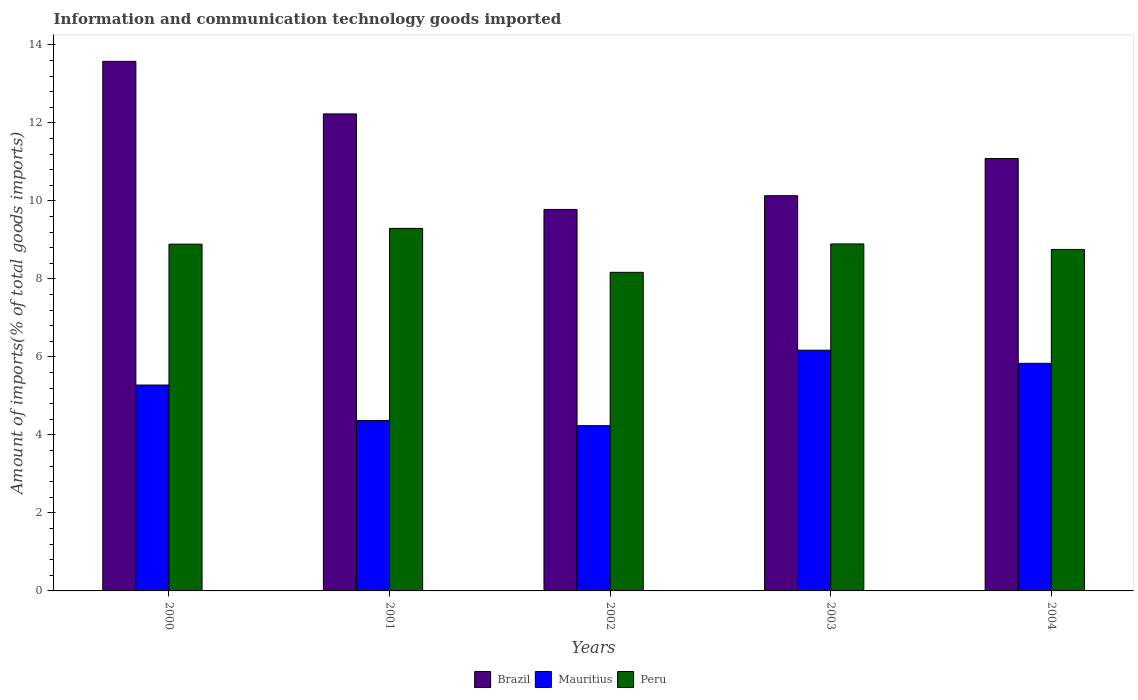How many groups of bars are there?
Give a very brief answer. 5. Are the number of bars on each tick of the X-axis equal?
Provide a succinct answer. Yes. What is the label of the 1st group of bars from the left?
Your answer should be very brief. 2000. In how many cases, is the number of bars for a given year not equal to the number of legend labels?
Keep it short and to the point. 0. What is the amount of goods imported in Mauritius in 2003?
Provide a short and direct response. 6.17. Across all years, what is the maximum amount of goods imported in Mauritius?
Provide a short and direct response. 6.17. Across all years, what is the minimum amount of goods imported in Peru?
Give a very brief answer. 8.17. In which year was the amount of goods imported in Peru minimum?
Provide a succinct answer. 2002. What is the total amount of goods imported in Mauritius in the graph?
Keep it short and to the point. 25.89. What is the difference between the amount of goods imported in Mauritius in 2001 and that in 2003?
Offer a very short reply. -1.8. What is the difference between the amount of goods imported in Mauritius in 2001 and the amount of goods imported in Brazil in 2002?
Offer a terse response. -5.41. What is the average amount of goods imported in Mauritius per year?
Offer a very short reply. 5.18. In the year 2003, what is the difference between the amount of goods imported in Mauritius and amount of goods imported in Brazil?
Your response must be concise. -3.96. In how many years, is the amount of goods imported in Mauritius greater than 6.4 %?
Give a very brief answer. 0. What is the ratio of the amount of goods imported in Mauritius in 2000 to that in 2001?
Your answer should be compact. 1.21. Is the amount of goods imported in Peru in 2001 less than that in 2003?
Your response must be concise. No. What is the difference between the highest and the second highest amount of goods imported in Peru?
Your answer should be very brief. 0.4. What is the difference between the highest and the lowest amount of goods imported in Brazil?
Offer a terse response. 3.8. What does the 2nd bar from the right in 2004 represents?
Your answer should be very brief. Mauritius. Is it the case that in every year, the sum of the amount of goods imported in Brazil and amount of goods imported in Peru is greater than the amount of goods imported in Mauritius?
Offer a very short reply. Yes. Are the values on the major ticks of Y-axis written in scientific E-notation?
Provide a short and direct response. No. Does the graph contain any zero values?
Keep it short and to the point. No. How many legend labels are there?
Your response must be concise. 3. How are the legend labels stacked?
Offer a very short reply. Horizontal. What is the title of the graph?
Your response must be concise. Information and communication technology goods imported. What is the label or title of the Y-axis?
Offer a very short reply. Amount of imports(% of total goods imports). What is the Amount of imports(% of total goods imports) of Brazil in 2000?
Your answer should be very brief. 13.58. What is the Amount of imports(% of total goods imports) of Mauritius in 2000?
Offer a terse response. 5.28. What is the Amount of imports(% of total goods imports) of Peru in 2000?
Your response must be concise. 8.89. What is the Amount of imports(% of total goods imports) in Brazil in 2001?
Keep it short and to the point. 12.23. What is the Amount of imports(% of total goods imports) of Mauritius in 2001?
Make the answer very short. 4.37. What is the Amount of imports(% of total goods imports) in Peru in 2001?
Offer a terse response. 9.3. What is the Amount of imports(% of total goods imports) in Brazil in 2002?
Give a very brief answer. 9.78. What is the Amount of imports(% of total goods imports) of Mauritius in 2002?
Your answer should be compact. 4.24. What is the Amount of imports(% of total goods imports) in Peru in 2002?
Provide a short and direct response. 8.17. What is the Amount of imports(% of total goods imports) in Brazil in 2003?
Your answer should be compact. 10.13. What is the Amount of imports(% of total goods imports) of Mauritius in 2003?
Give a very brief answer. 6.17. What is the Amount of imports(% of total goods imports) in Peru in 2003?
Your response must be concise. 8.9. What is the Amount of imports(% of total goods imports) in Brazil in 2004?
Keep it short and to the point. 11.09. What is the Amount of imports(% of total goods imports) in Mauritius in 2004?
Offer a terse response. 5.84. What is the Amount of imports(% of total goods imports) of Peru in 2004?
Provide a succinct answer. 8.76. Across all years, what is the maximum Amount of imports(% of total goods imports) in Brazil?
Provide a short and direct response. 13.58. Across all years, what is the maximum Amount of imports(% of total goods imports) in Mauritius?
Provide a short and direct response. 6.17. Across all years, what is the maximum Amount of imports(% of total goods imports) in Peru?
Offer a terse response. 9.3. Across all years, what is the minimum Amount of imports(% of total goods imports) in Brazil?
Provide a succinct answer. 9.78. Across all years, what is the minimum Amount of imports(% of total goods imports) of Mauritius?
Your answer should be very brief. 4.24. Across all years, what is the minimum Amount of imports(% of total goods imports) of Peru?
Give a very brief answer. 8.17. What is the total Amount of imports(% of total goods imports) of Brazil in the graph?
Provide a short and direct response. 56.81. What is the total Amount of imports(% of total goods imports) in Mauritius in the graph?
Make the answer very short. 25.89. What is the total Amount of imports(% of total goods imports) of Peru in the graph?
Provide a succinct answer. 44.01. What is the difference between the Amount of imports(% of total goods imports) of Brazil in 2000 and that in 2001?
Give a very brief answer. 1.35. What is the difference between the Amount of imports(% of total goods imports) in Mauritius in 2000 and that in 2001?
Keep it short and to the point. 0.91. What is the difference between the Amount of imports(% of total goods imports) of Peru in 2000 and that in 2001?
Offer a very short reply. -0.4. What is the difference between the Amount of imports(% of total goods imports) of Brazil in 2000 and that in 2002?
Provide a succinct answer. 3.8. What is the difference between the Amount of imports(% of total goods imports) in Mauritius in 2000 and that in 2002?
Provide a short and direct response. 1.04. What is the difference between the Amount of imports(% of total goods imports) in Peru in 2000 and that in 2002?
Your response must be concise. 0.72. What is the difference between the Amount of imports(% of total goods imports) in Brazil in 2000 and that in 2003?
Your answer should be compact. 3.44. What is the difference between the Amount of imports(% of total goods imports) of Mauritius in 2000 and that in 2003?
Ensure brevity in your answer.  -0.89. What is the difference between the Amount of imports(% of total goods imports) of Peru in 2000 and that in 2003?
Make the answer very short. -0.01. What is the difference between the Amount of imports(% of total goods imports) in Brazil in 2000 and that in 2004?
Make the answer very short. 2.49. What is the difference between the Amount of imports(% of total goods imports) of Mauritius in 2000 and that in 2004?
Keep it short and to the point. -0.56. What is the difference between the Amount of imports(% of total goods imports) of Peru in 2000 and that in 2004?
Your answer should be compact. 0.14. What is the difference between the Amount of imports(% of total goods imports) of Brazil in 2001 and that in 2002?
Offer a very short reply. 2.45. What is the difference between the Amount of imports(% of total goods imports) in Mauritius in 2001 and that in 2002?
Offer a terse response. 0.13. What is the difference between the Amount of imports(% of total goods imports) of Peru in 2001 and that in 2002?
Make the answer very short. 1.13. What is the difference between the Amount of imports(% of total goods imports) in Brazil in 2001 and that in 2003?
Your answer should be compact. 2.1. What is the difference between the Amount of imports(% of total goods imports) of Mauritius in 2001 and that in 2003?
Ensure brevity in your answer.  -1.8. What is the difference between the Amount of imports(% of total goods imports) in Peru in 2001 and that in 2003?
Ensure brevity in your answer.  0.4. What is the difference between the Amount of imports(% of total goods imports) of Brazil in 2001 and that in 2004?
Your response must be concise. 1.14. What is the difference between the Amount of imports(% of total goods imports) in Mauritius in 2001 and that in 2004?
Your answer should be compact. -1.46. What is the difference between the Amount of imports(% of total goods imports) in Peru in 2001 and that in 2004?
Keep it short and to the point. 0.54. What is the difference between the Amount of imports(% of total goods imports) in Brazil in 2002 and that in 2003?
Give a very brief answer. -0.35. What is the difference between the Amount of imports(% of total goods imports) in Mauritius in 2002 and that in 2003?
Make the answer very short. -1.94. What is the difference between the Amount of imports(% of total goods imports) in Peru in 2002 and that in 2003?
Provide a short and direct response. -0.73. What is the difference between the Amount of imports(% of total goods imports) in Brazil in 2002 and that in 2004?
Provide a succinct answer. -1.31. What is the difference between the Amount of imports(% of total goods imports) of Mauritius in 2002 and that in 2004?
Your response must be concise. -1.6. What is the difference between the Amount of imports(% of total goods imports) in Peru in 2002 and that in 2004?
Your response must be concise. -0.59. What is the difference between the Amount of imports(% of total goods imports) in Brazil in 2003 and that in 2004?
Offer a very short reply. -0.95. What is the difference between the Amount of imports(% of total goods imports) in Mauritius in 2003 and that in 2004?
Ensure brevity in your answer.  0.34. What is the difference between the Amount of imports(% of total goods imports) of Peru in 2003 and that in 2004?
Offer a very short reply. 0.14. What is the difference between the Amount of imports(% of total goods imports) of Brazil in 2000 and the Amount of imports(% of total goods imports) of Mauritius in 2001?
Provide a succinct answer. 9.21. What is the difference between the Amount of imports(% of total goods imports) of Brazil in 2000 and the Amount of imports(% of total goods imports) of Peru in 2001?
Give a very brief answer. 4.28. What is the difference between the Amount of imports(% of total goods imports) in Mauritius in 2000 and the Amount of imports(% of total goods imports) in Peru in 2001?
Provide a short and direct response. -4.02. What is the difference between the Amount of imports(% of total goods imports) of Brazil in 2000 and the Amount of imports(% of total goods imports) of Mauritius in 2002?
Provide a short and direct response. 9.34. What is the difference between the Amount of imports(% of total goods imports) of Brazil in 2000 and the Amount of imports(% of total goods imports) of Peru in 2002?
Offer a very short reply. 5.41. What is the difference between the Amount of imports(% of total goods imports) in Mauritius in 2000 and the Amount of imports(% of total goods imports) in Peru in 2002?
Offer a terse response. -2.89. What is the difference between the Amount of imports(% of total goods imports) of Brazil in 2000 and the Amount of imports(% of total goods imports) of Mauritius in 2003?
Your answer should be very brief. 7.41. What is the difference between the Amount of imports(% of total goods imports) of Brazil in 2000 and the Amount of imports(% of total goods imports) of Peru in 2003?
Your response must be concise. 4.68. What is the difference between the Amount of imports(% of total goods imports) of Mauritius in 2000 and the Amount of imports(% of total goods imports) of Peru in 2003?
Your response must be concise. -3.62. What is the difference between the Amount of imports(% of total goods imports) in Brazil in 2000 and the Amount of imports(% of total goods imports) in Mauritius in 2004?
Provide a short and direct response. 7.74. What is the difference between the Amount of imports(% of total goods imports) of Brazil in 2000 and the Amount of imports(% of total goods imports) of Peru in 2004?
Your answer should be very brief. 4.82. What is the difference between the Amount of imports(% of total goods imports) in Mauritius in 2000 and the Amount of imports(% of total goods imports) in Peru in 2004?
Your response must be concise. -3.48. What is the difference between the Amount of imports(% of total goods imports) of Brazil in 2001 and the Amount of imports(% of total goods imports) of Mauritius in 2002?
Provide a short and direct response. 7.99. What is the difference between the Amount of imports(% of total goods imports) of Brazil in 2001 and the Amount of imports(% of total goods imports) of Peru in 2002?
Provide a short and direct response. 4.06. What is the difference between the Amount of imports(% of total goods imports) in Mauritius in 2001 and the Amount of imports(% of total goods imports) in Peru in 2002?
Provide a short and direct response. -3.8. What is the difference between the Amount of imports(% of total goods imports) in Brazil in 2001 and the Amount of imports(% of total goods imports) in Mauritius in 2003?
Provide a short and direct response. 6.06. What is the difference between the Amount of imports(% of total goods imports) in Brazil in 2001 and the Amount of imports(% of total goods imports) in Peru in 2003?
Provide a succinct answer. 3.33. What is the difference between the Amount of imports(% of total goods imports) of Mauritius in 2001 and the Amount of imports(% of total goods imports) of Peru in 2003?
Offer a terse response. -4.53. What is the difference between the Amount of imports(% of total goods imports) in Brazil in 2001 and the Amount of imports(% of total goods imports) in Mauritius in 2004?
Ensure brevity in your answer.  6.4. What is the difference between the Amount of imports(% of total goods imports) in Brazil in 2001 and the Amount of imports(% of total goods imports) in Peru in 2004?
Offer a terse response. 3.48. What is the difference between the Amount of imports(% of total goods imports) of Mauritius in 2001 and the Amount of imports(% of total goods imports) of Peru in 2004?
Provide a short and direct response. -4.38. What is the difference between the Amount of imports(% of total goods imports) of Brazil in 2002 and the Amount of imports(% of total goods imports) of Mauritius in 2003?
Offer a terse response. 3.61. What is the difference between the Amount of imports(% of total goods imports) in Brazil in 2002 and the Amount of imports(% of total goods imports) in Peru in 2003?
Your response must be concise. 0.88. What is the difference between the Amount of imports(% of total goods imports) of Mauritius in 2002 and the Amount of imports(% of total goods imports) of Peru in 2003?
Provide a succinct answer. -4.66. What is the difference between the Amount of imports(% of total goods imports) in Brazil in 2002 and the Amount of imports(% of total goods imports) in Mauritius in 2004?
Your response must be concise. 3.95. What is the difference between the Amount of imports(% of total goods imports) of Brazil in 2002 and the Amount of imports(% of total goods imports) of Peru in 2004?
Make the answer very short. 1.03. What is the difference between the Amount of imports(% of total goods imports) in Mauritius in 2002 and the Amount of imports(% of total goods imports) in Peru in 2004?
Make the answer very short. -4.52. What is the difference between the Amount of imports(% of total goods imports) of Brazil in 2003 and the Amount of imports(% of total goods imports) of Mauritius in 2004?
Make the answer very short. 4.3. What is the difference between the Amount of imports(% of total goods imports) in Brazil in 2003 and the Amount of imports(% of total goods imports) in Peru in 2004?
Your answer should be very brief. 1.38. What is the difference between the Amount of imports(% of total goods imports) in Mauritius in 2003 and the Amount of imports(% of total goods imports) in Peru in 2004?
Provide a succinct answer. -2.58. What is the average Amount of imports(% of total goods imports) of Brazil per year?
Offer a very short reply. 11.36. What is the average Amount of imports(% of total goods imports) of Mauritius per year?
Keep it short and to the point. 5.18. What is the average Amount of imports(% of total goods imports) of Peru per year?
Offer a very short reply. 8.8. In the year 2000, what is the difference between the Amount of imports(% of total goods imports) of Brazil and Amount of imports(% of total goods imports) of Mauritius?
Ensure brevity in your answer.  8.3. In the year 2000, what is the difference between the Amount of imports(% of total goods imports) of Brazil and Amount of imports(% of total goods imports) of Peru?
Offer a very short reply. 4.69. In the year 2000, what is the difference between the Amount of imports(% of total goods imports) in Mauritius and Amount of imports(% of total goods imports) in Peru?
Provide a succinct answer. -3.61. In the year 2001, what is the difference between the Amount of imports(% of total goods imports) in Brazil and Amount of imports(% of total goods imports) in Mauritius?
Ensure brevity in your answer.  7.86. In the year 2001, what is the difference between the Amount of imports(% of total goods imports) of Brazil and Amount of imports(% of total goods imports) of Peru?
Offer a very short reply. 2.94. In the year 2001, what is the difference between the Amount of imports(% of total goods imports) of Mauritius and Amount of imports(% of total goods imports) of Peru?
Offer a terse response. -4.93. In the year 2002, what is the difference between the Amount of imports(% of total goods imports) in Brazil and Amount of imports(% of total goods imports) in Mauritius?
Keep it short and to the point. 5.54. In the year 2002, what is the difference between the Amount of imports(% of total goods imports) of Brazil and Amount of imports(% of total goods imports) of Peru?
Your answer should be very brief. 1.61. In the year 2002, what is the difference between the Amount of imports(% of total goods imports) of Mauritius and Amount of imports(% of total goods imports) of Peru?
Your response must be concise. -3.93. In the year 2003, what is the difference between the Amount of imports(% of total goods imports) in Brazil and Amount of imports(% of total goods imports) in Mauritius?
Your answer should be compact. 3.96. In the year 2003, what is the difference between the Amount of imports(% of total goods imports) of Brazil and Amount of imports(% of total goods imports) of Peru?
Give a very brief answer. 1.24. In the year 2003, what is the difference between the Amount of imports(% of total goods imports) of Mauritius and Amount of imports(% of total goods imports) of Peru?
Offer a terse response. -2.72. In the year 2004, what is the difference between the Amount of imports(% of total goods imports) of Brazil and Amount of imports(% of total goods imports) of Mauritius?
Provide a succinct answer. 5.25. In the year 2004, what is the difference between the Amount of imports(% of total goods imports) of Brazil and Amount of imports(% of total goods imports) of Peru?
Offer a very short reply. 2.33. In the year 2004, what is the difference between the Amount of imports(% of total goods imports) in Mauritius and Amount of imports(% of total goods imports) in Peru?
Ensure brevity in your answer.  -2.92. What is the ratio of the Amount of imports(% of total goods imports) in Brazil in 2000 to that in 2001?
Your response must be concise. 1.11. What is the ratio of the Amount of imports(% of total goods imports) in Mauritius in 2000 to that in 2001?
Provide a succinct answer. 1.21. What is the ratio of the Amount of imports(% of total goods imports) in Peru in 2000 to that in 2001?
Your answer should be very brief. 0.96. What is the ratio of the Amount of imports(% of total goods imports) in Brazil in 2000 to that in 2002?
Provide a short and direct response. 1.39. What is the ratio of the Amount of imports(% of total goods imports) of Mauritius in 2000 to that in 2002?
Give a very brief answer. 1.25. What is the ratio of the Amount of imports(% of total goods imports) of Peru in 2000 to that in 2002?
Keep it short and to the point. 1.09. What is the ratio of the Amount of imports(% of total goods imports) of Brazil in 2000 to that in 2003?
Your answer should be very brief. 1.34. What is the ratio of the Amount of imports(% of total goods imports) in Mauritius in 2000 to that in 2003?
Ensure brevity in your answer.  0.86. What is the ratio of the Amount of imports(% of total goods imports) of Peru in 2000 to that in 2003?
Make the answer very short. 1. What is the ratio of the Amount of imports(% of total goods imports) of Brazil in 2000 to that in 2004?
Your answer should be very brief. 1.22. What is the ratio of the Amount of imports(% of total goods imports) of Mauritius in 2000 to that in 2004?
Provide a succinct answer. 0.9. What is the ratio of the Amount of imports(% of total goods imports) of Peru in 2000 to that in 2004?
Offer a terse response. 1.02. What is the ratio of the Amount of imports(% of total goods imports) of Brazil in 2001 to that in 2002?
Your answer should be compact. 1.25. What is the ratio of the Amount of imports(% of total goods imports) of Mauritius in 2001 to that in 2002?
Offer a very short reply. 1.03. What is the ratio of the Amount of imports(% of total goods imports) in Peru in 2001 to that in 2002?
Offer a terse response. 1.14. What is the ratio of the Amount of imports(% of total goods imports) in Brazil in 2001 to that in 2003?
Provide a short and direct response. 1.21. What is the ratio of the Amount of imports(% of total goods imports) of Mauritius in 2001 to that in 2003?
Ensure brevity in your answer.  0.71. What is the ratio of the Amount of imports(% of total goods imports) of Peru in 2001 to that in 2003?
Your answer should be very brief. 1.04. What is the ratio of the Amount of imports(% of total goods imports) in Brazil in 2001 to that in 2004?
Ensure brevity in your answer.  1.1. What is the ratio of the Amount of imports(% of total goods imports) of Mauritius in 2001 to that in 2004?
Offer a very short reply. 0.75. What is the ratio of the Amount of imports(% of total goods imports) in Peru in 2001 to that in 2004?
Make the answer very short. 1.06. What is the ratio of the Amount of imports(% of total goods imports) of Brazil in 2002 to that in 2003?
Offer a very short reply. 0.97. What is the ratio of the Amount of imports(% of total goods imports) of Mauritius in 2002 to that in 2003?
Your response must be concise. 0.69. What is the ratio of the Amount of imports(% of total goods imports) of Peru in 2002 to that in 2003?
Your response must be concise. 0.92. What is the ratio of the Amount of imports(% of total goods imports) of Brazil in 2002 to that in 2004?
Offer a very short reply. 0.88. What is the ratio of the Amount of imports(% of total goods imports) in Mauritius in 2002 to that in 2004?
Your answer should be compact. 0.73. What is the ratio of the Amount of imports(% of total goods imports) in Peru in 2002 to that in 2004?
Keep it short and to the point. 0.93. What is the ratio of the Amount of imports(% of total goods imports) of Brazil in 2003 to that in 2004?
Your answer should be compact. 0.91. What is the ratio of the Amount of imports(% of total goods imports) in Mauritius in 2003 to that in 2004?
Keep it short and to the point. 1.06. What is the ratio of the Amount of imports(% of total goods imports) in Peru in 2003 to that in 2004?
Provide a succinct answer. 1.02. What is the difference between the highest and the second highest Amount of imports(% of total goods imports) in Brazil?
Your response must be concise. 1.35. What is the difference between the highest and the second highest Amount of imports(% of total goods imports) of Mauritius?
Provide a succinct answer. 0.34. What is the difference between the highest and the second highest Amount of imports(% of total goods imports) of Peru?
Offer a very short reply. 0.4. What is the difference between the highest and the lowest Amount of imports(% of total goods imports) in Brazil?
Give a very brief answer. 3.8. What is the difference between the highest and the lowest Amount of imports(% of total goods imports) in Mauritius?
Provide a succinct answer. 1.94. What is the difference between the highest and the lowest Amount of imports(% of total goods imports) of Peru?
Provide a short and direct response. 1.13. 